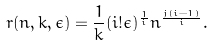Convert formula to latex. <formula><loc_0><loc_0><loc_500><loc_500>r ( n , k , \epsilon ) = \frac { 1 } { k } ( i ! \epsilon ) ^ { \frac { 1 } { i } } n ^ { \frac { j ( i - 1 ) } { i } } .</formula> 